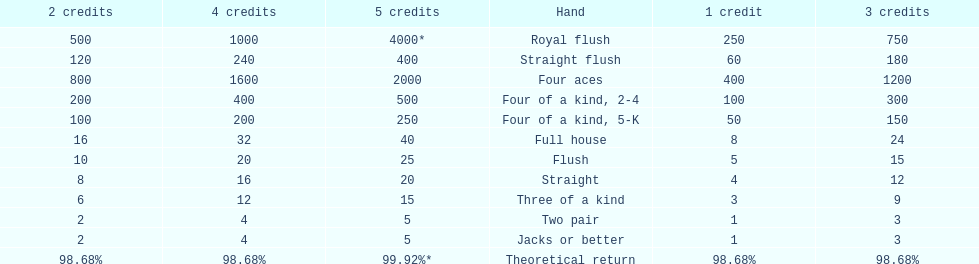Is a 2 credit full house the same as a 5 credit three of a kind? No. 